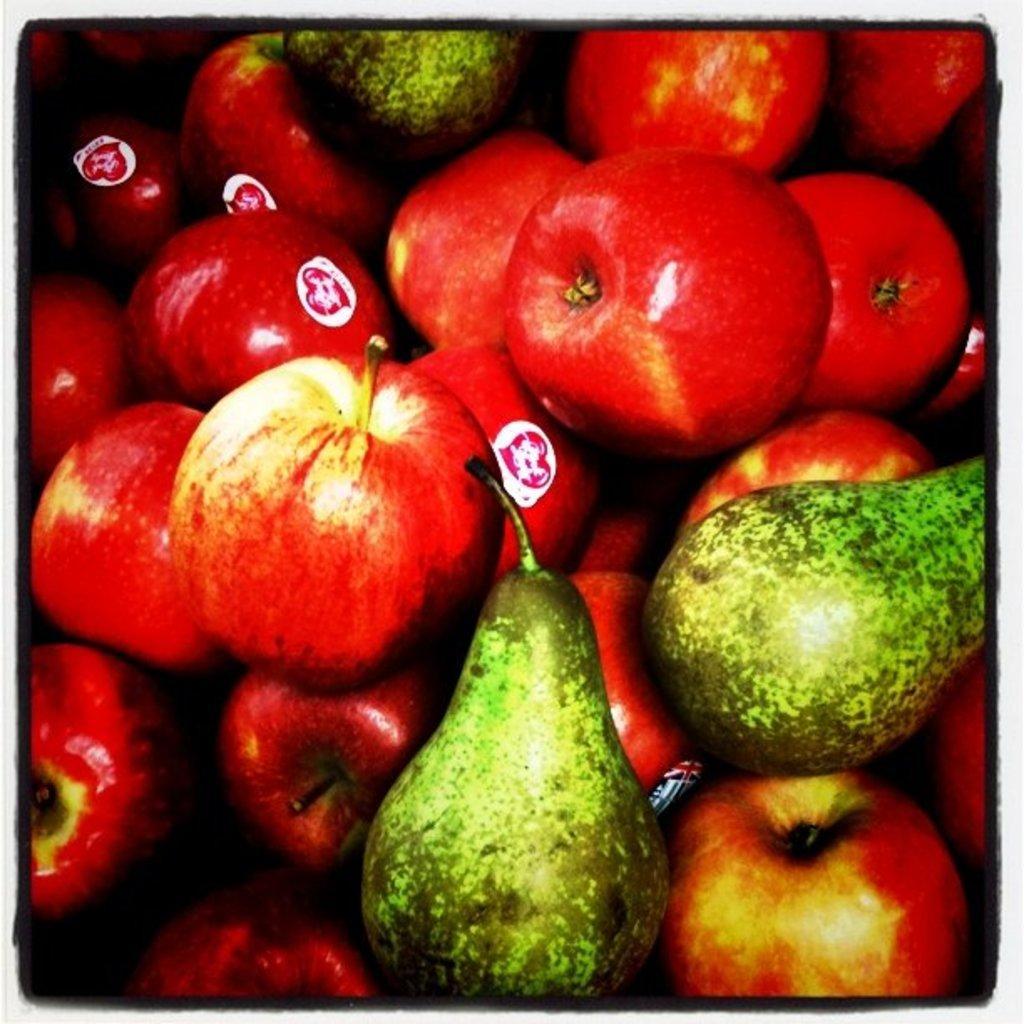Describe this image in one or two sentences. In this image i can see many types of fruits. 